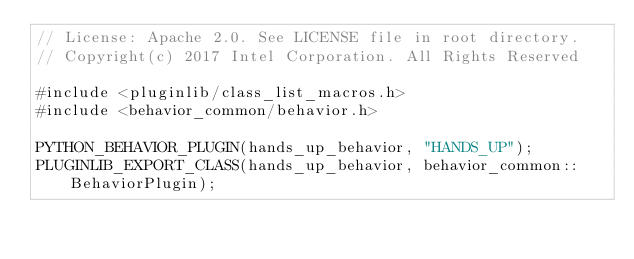<code> <loc_0><loc_0><loc_500><loc_500><_C++_>// License: Apache 2.0. See LICENSE file in root directory.
// Copyright(c) 2017 Intel Corporation. All Rights Reserved

#include <pluginlib/class_list_macros.h>
#include <behavior_common/behavior.h>

PYTHON_BEHAVIOR_PLUGIN(hands_up_behavior, "HANDS_UP");
PLUGINLIB_EXPORT_CLASS(hands_up_behavior, behavior_common::BehaviorPlugin);
</code> 